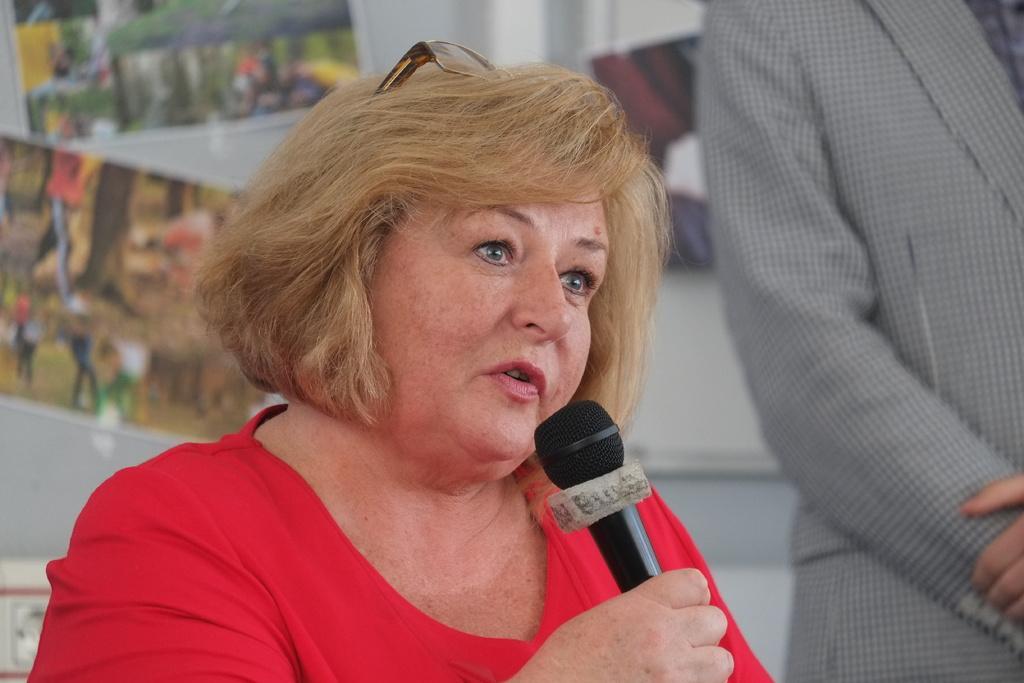Could you give a brief overview of what you see in this image? In this image i can see a woman is holding a microphone in her hand. 